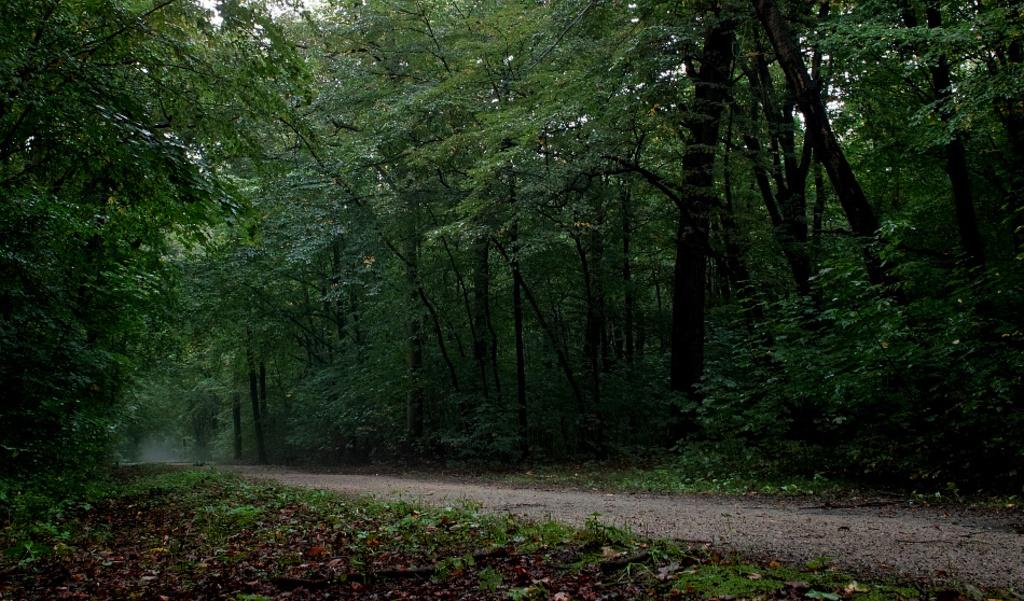What can be seen in the image that people might walk on? There is a path in the image that people might walk on. What type of natural environment surrounds the path? There are many trees around the path. What might be found on the ground near the path? Dry leaves are present in the image. Where is the harbor located in the image? There is no harbor present in the image; it features a path surrounded by trees and dry leaves. How many deer can be seen in the image? There are no deer present in the image. 